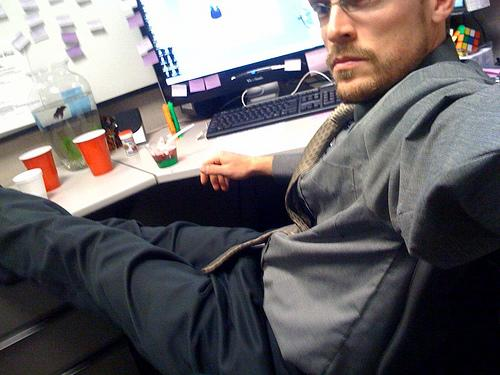What kind of puzzle or game object can you see in the image? Where is it located? An unsolved Rubik's Cube is visible, set in the corner of the desk. What kind of fish is in the clear vase, and where is the vase located on the desktop? A black beta fish is in the clear vase, which is located near the edge of the desktop with a container of fish food nearby. In the image, is the man interacting with any of the objects on the desk directly? If so, how? No, the man is not directly interacting with any of the objects on the desk. He has his feet up on the desk and is looking at the computer monitor. What types of desserts or snacks are present in the image? Briefly describe them. A red and green parfait dessert is on the desk, with colorful layers in a tall glass. Analyze the overall sentiment or vibe of the image. What do you think the man could be feeling? The image has a busy, cluttered, or work-related vibe. The man could be feeling focused, determined or possibly stressed due to the surrounding items and his facial expression. How many computer-related objects are there in the scene, and what are their specific details? There are four computer-related objects: a computer monitor on the desktop with sticky notes at the bottom, a black computer keyboard, a small silver and black speaker, and a mouse next to the keyboard.  Describe the appearance and color of the necktie that the man is wearing. The man is wearing a brown necktie with gold and gray print on it, giving it aprinted pattern. Identify the objects that could be classified as office supplies and describe their colors. Yellow and green highlighters, white noteit and pink noteit sticking to the computer monitor, small purple post-its, yellow and green markit on the desktop. Mention the type of drinkware and their colors that you see on the desk. Two red drinking cups, a white drinking water cup, a red plastic cup with a white trim, and an orange disposable plastic cup. 